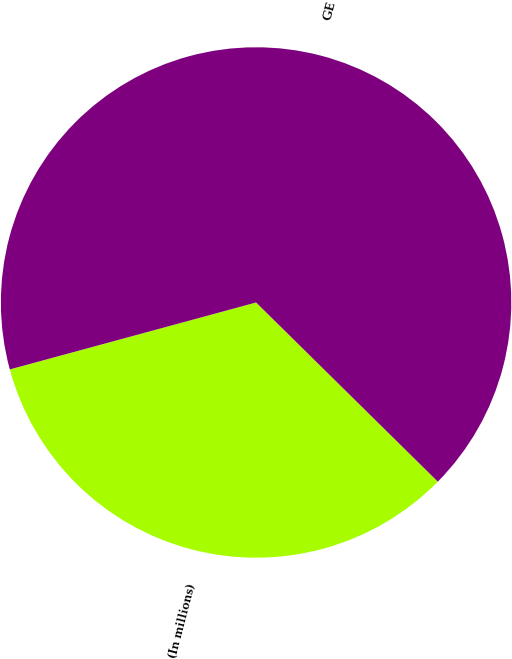Convert chart. <chart><loc_0><loc_0><loc_500><loc_500><pie_chart><fcel>(In millions)<fcel>GE<nl><fcel>33.39%<fcel>66.61%<nl></chart> 